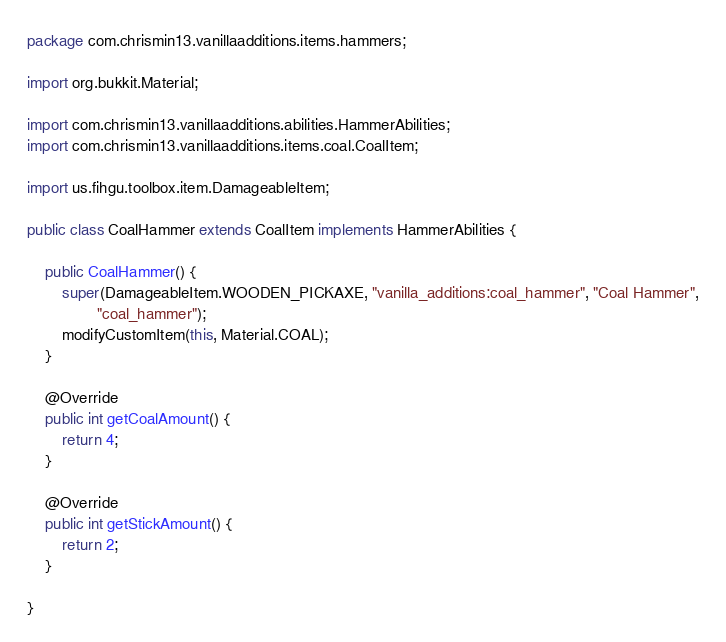<code> <loc_0><loc_0><loc_500><loc_500><_Java_>package com.chrismin13.vanillaadditions.items.hammers;

import org.bukkit.Material;

import com.chrismin13.vanillaadditions.abilities.HammerAbilities;
import com.chrismin13.vanillaadditions.items.coal.CoalItem;

import us.fihgu.toolbox.item.DamageableItem;

public class CoalHammer extends CoalItem implements HammerAbilities {

	public CoalHammer() {
		super(DamageableItem.WOODEN_PICKAXE, "vanilla_additions:coal_hammer", "Coal Hammer",
				"coal_hammer");
		modifyCustomItem(this, Material.COAL);
	}

	@Override
	public int getCoalAmount() {
		return 4;
	}

	@Override
	public int getStickAmount() {
		return 2;
	}

}
</code> 